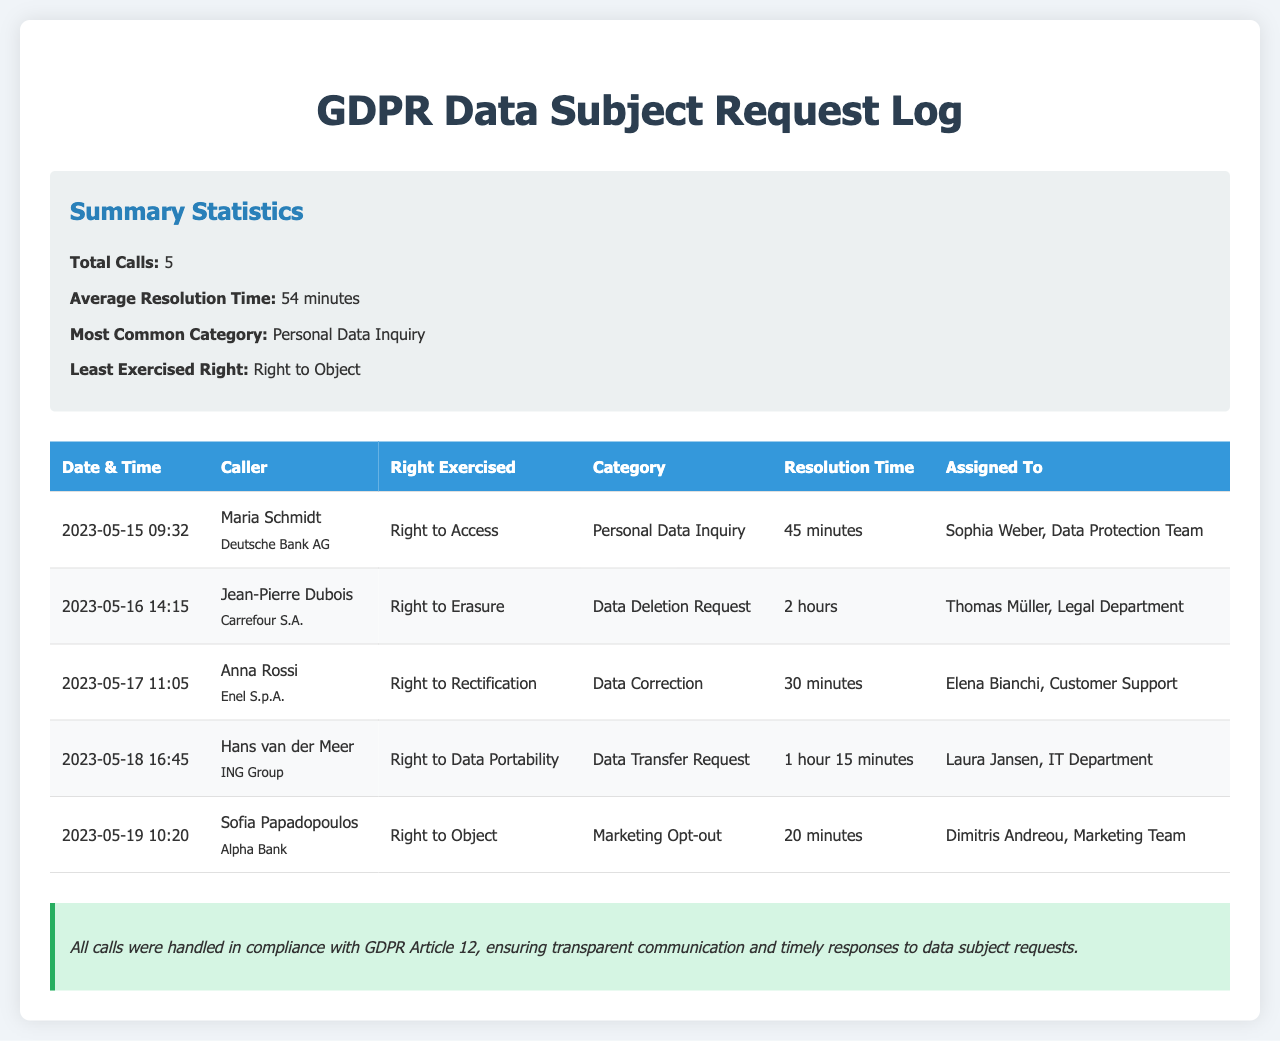What is the total number of calls? The total number of calls is mentioned in the summary statistics section of the document.
Answer: 5 What is the average resolution time? The average resolution time is stated in the summary statistics and calculated from all calls logged.
Answer: 54 minutes Who is the caller for the first call? The first caller is listed in the first row of the table under the "Caller" column.
Answer: Maria Schmidt What is the most common category of calls? The most common category is mentioned in the summary statistics, which summarizes the data effectively.
Answer: Personal Data Inquiry Which right was exercised by Sofia Papadopoulos? The right exercised by Sofia Papadopoulos is indicated in the last row of the table.
Answer: Right to Object How long did it take to resolve the call from Anna Rossi? The resolution time for Anna Rossi's call can be found in the table under "Resolution Time."
Answer: 30 minutes What date did the call for the Right to Erasure occur? The date is listed in the "Date & Time" column for Jean-Pierre Dubois's call in the table.
Answer: 2023-05-16 Who was assigned to handle the call regarding the Right to Data Portability? The assignee for the Right to Data Portability is given in the "Assigned To" column of the table.
Answer: Laura Jansen, IT Department What was the least exercised right among the calls? The least exercised right is noted in the summary statistics section of the document.
Answer: Right to Object 